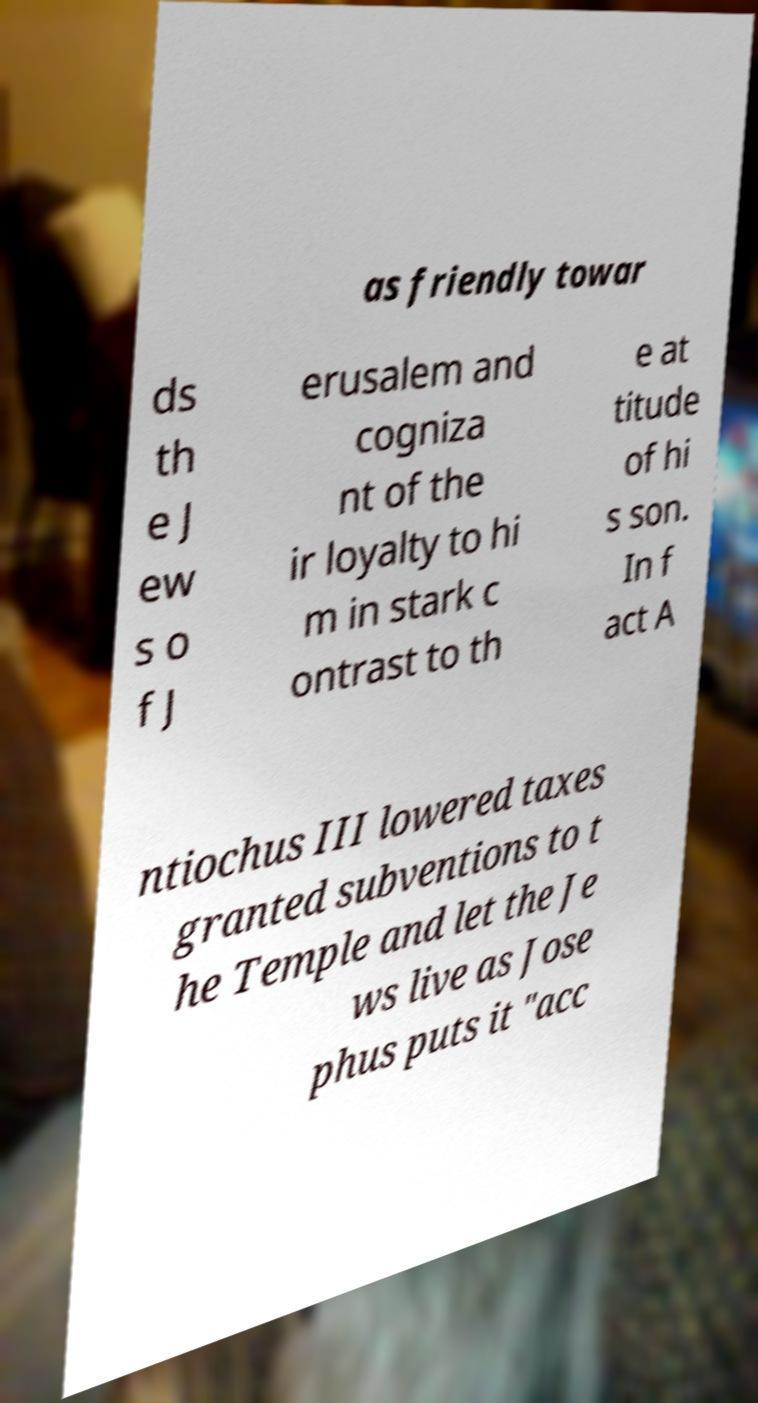Please read and relay the text visible in this image. What does it say? as friendly towar ds th e J ew s o f J erusalem and cogniza nt of the ir loyalty to hi m in stark c ontrast to th e at titude of hi s son. In f act A ntiochus III lowered taxes granted subventions to t he Temple and let the Je ws live as Jose phus puts it "acc 